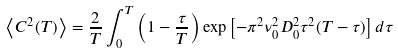<formula> <loc_0><loc_0><loc_500><loc_500>\left < C ^ { 2 } ( T ) \right > = \frac { 2 } { T } \int ^ { T } _ { 0 } \left ( 1 - \frac { \tau } { T } \right ) \exp \left [ - \pi ^ { 2 } \nu _ { 0 } ^ { 2 } D ^ { 2 } _ { 0 } \tau ^ { 2 } ( T - \tau ) \right ] d \tau</formula> 